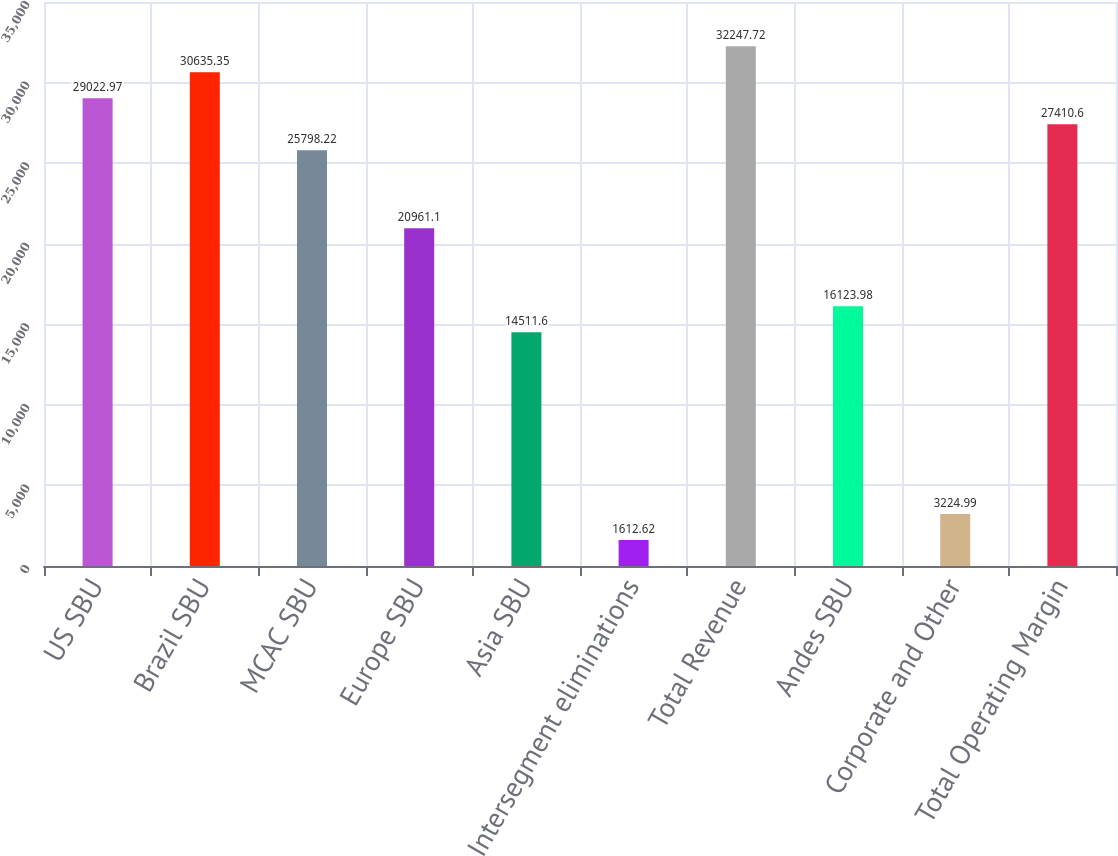Convert chart. <chart><loc_0><loc_0><loc_500><loc_500><bar_chart><fcel>US SBU<fcel>Brazil SBU<fcel>MCAC SBU<fcel>Europe SBU<fcel>Asia SBU<fcel>Intersegment eliminations<fcel>Total Revenue<fcel>Andes SBU<fcel>Corporate and Other<fcel>Total Operating Margin<nl><fcel>29023<fcel>30635.3<fcel>25798.2<fcel>20961.1<fcel>14511.6<fcel>1612.62<fcel>32247.7<fcel>16124<fcel>3224.99<fcel>27410.6<nl></chart> 